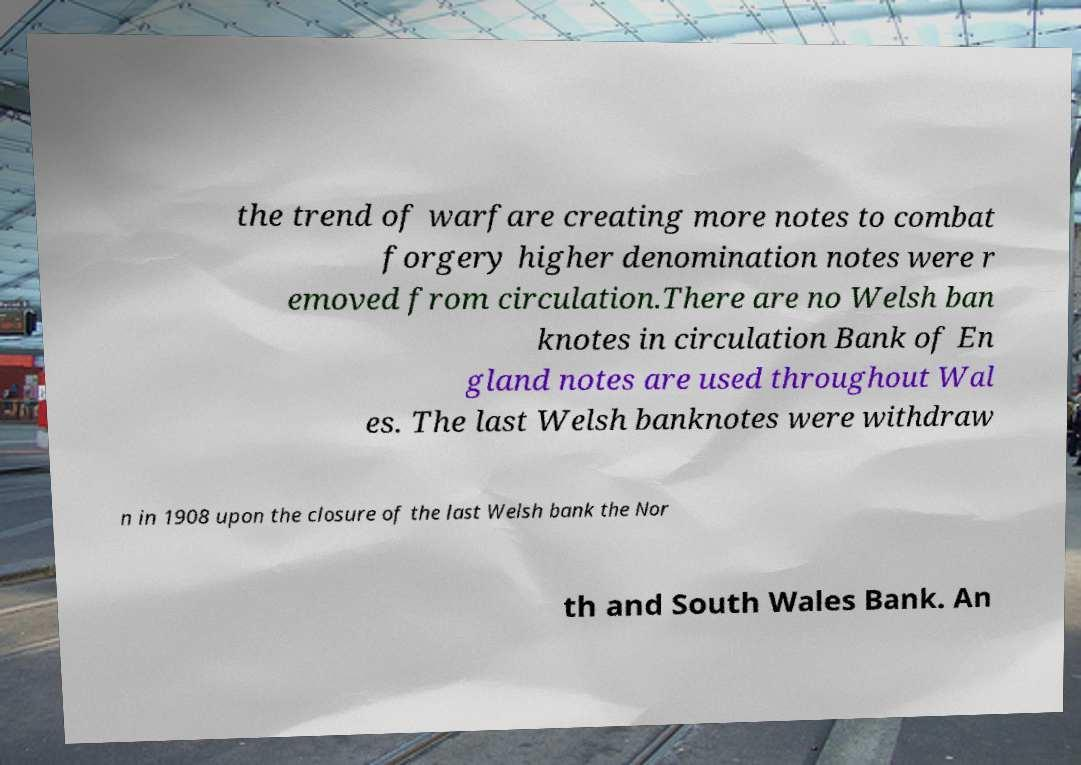There's text embedded in this image that I need extracted. Can you transcribe it verbatim? the trend of warfare creating more notes to combat forgery higher denomination notes were r emoved from circulation.There are no Welsh ban knotes in circulation Bank of En gland notes are used throughout Wal es. The last Welsh banknotes were withdraw n in 1908 upon the closure of the last Welsh bank the Nor th and South Wales Bank. An 